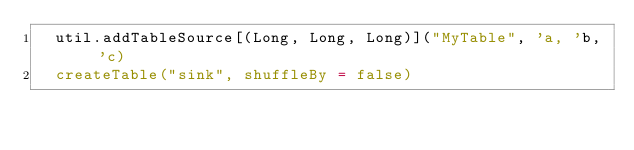<code> <loc_0><loc_0><loc_500><loc_500><_Scala_>  util.addTableSource[(Long, Long, Long)]("MyTable", 'a, 'b, 'c)
  createTable("sink", shuffleBy = false)
</code> 